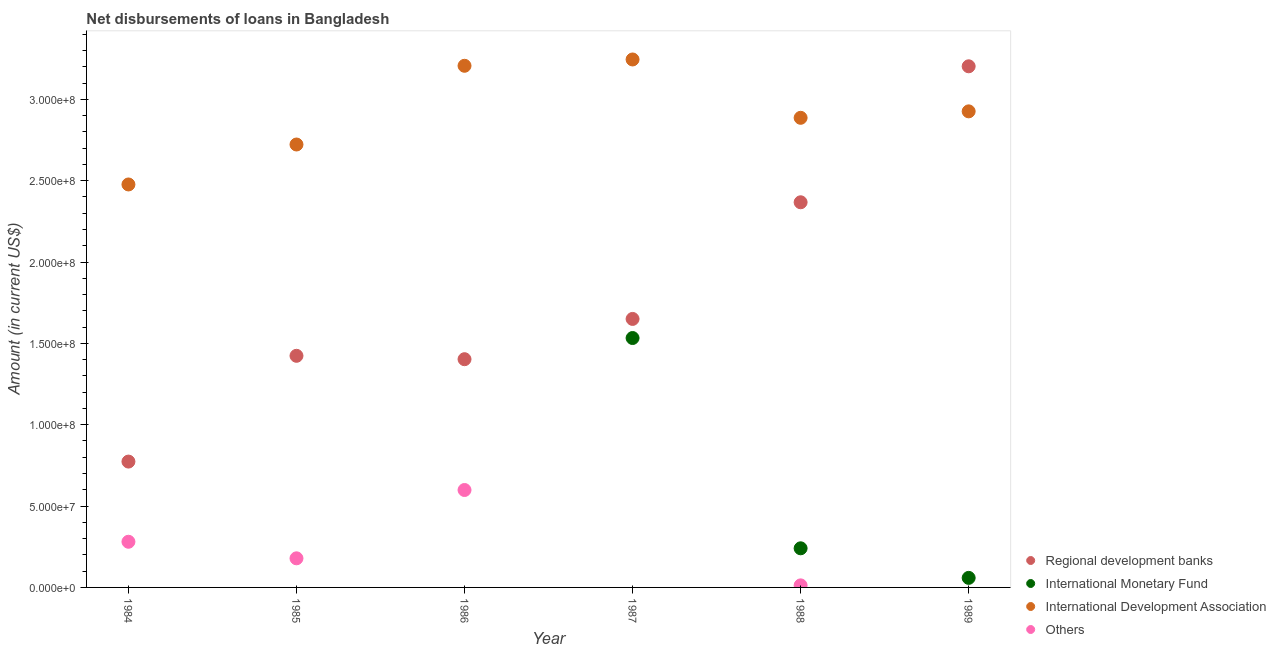How many different coloured dotlines are there?
Your answer should be very brief. 4. What is the amount of loan disimbursed by international monetary fund in 1989?
Make the answer very short. 5.87e+06. Across all years, what is the maximum amount of loan disimbursed by international monetary fund?
Give a very brief answer. 1.53e+08. Across all years, what is the minimum amount of loan disimbursed by international development association?
Keep it short and to the point. 2.48e+08. What is the total amount of loan disimbursed by other organisations in the graph?
Your answer should be compact. 1.07e+08. What is the difference between the amount of loan disimbursed by international development association in 1986 and that in 1989?
Offer a very short reply. 2.80e+07. What is the difference between the amount of loan disimbursed by regional development banks in 1985 and the amount of loan disimbursed by international development association in 1986?
Your answer should be very brief. -1.78e+08. What is the average amount of loan disimbursed by international monetary fund per year?
Offer a terse response. 3.05e+07. In the year 1984, what is the difference between the amount of loan disimbursed by regional development banks and amount of loan disimbursed by international development association?
Your answer should be compact. -1.70e+08. In how many years, is the amount of loan disimbursed by regional development banks greater than 320000000 US$?
Ensure brevity in your answer.  1. What is the ratio of the amount of loan disimbursed by international development association in 1984 to that in 1987?
Your response must be concise. 0.76. Is the amount of loan disimbursed by other organisations in 1985 less than that in 1988?
Offer a very short reply. No. What is the difference between the highest and the second highest amount of loan disimbursed by other organisations?
Ensure brevity in your answer.  3.18e+07. What is the difference between the highest and the lowest amount of loan disimbursed by regional development banks?
Your response must be concise. 2.43e+08. Is the sum of the amount of loan disimbursed by international development association in 1985 and 1986 greater than the maximum amount of loan disimbursed by regional development banks across all years?
Provide a succinct answer. Yes. Is it the case that in every year, the sum of the amount of loan disimbursed by international monetary fund and amount of loan disimbursed by international development association is greater than the sum of amount of loan disimbursed by other organisations and amount of loan disimbursed by regional development banks?
Ensure brevity in your answer.  No. Is the amount of loan disimbursed by other organisations strictly less than the amount of loan disimbursed by international development association over the years?
Make the answer very short. Yes. How many dotlines are there?
Offer a terse response. 4. Are the values on the major ticks of Y-axis written in scientific E-notation?
Give a very brief answer. Yes. Does the graph contain any zero values?
Ensure brevity in your answer.  Yes. Does the graph contain grids?
Your answer should be very brief. No. How are the legend labels stacked?
Your response must be concise. Vertical. What is the title of the graph?
Provide a short and direct response. Net disbursements of loans in Bangladesh. Does "Other expenses" appear as one of the legend labels in the graph?
Your response must be concise. No. What is the Amount (in current US$) of Regional development banks in 1984?
Provide a succinct answer. 7.73e+07. What is the Amount (in current US$) of International Development Association in 1984?
Your response must be concise. 2.48e+08. What is the Amount (in current US$) of Others in 1984?
Make the answer very short. 2.81e+07. What is the Amount (in current US$) in Regional development banks in 1985?
Your response must be concise. 1.42e+08. What is the Amount (in current US$) of International Development Association in 1985?
Provide a short and direct response. 2.72e+08. What is the Amount (in current US$) in Others in 1985?
Your answer should be very brief. 1.79e+07. What is the Amount (in current US$) in Regional development banks in 1986?
Offer a very short reply. 1.40e+08. What is the Amount (in current US$) of International Monetary Fund in 1986?
Provide a succinct answer. 0. What is the Amount (in current US$) in International Development Association in 1986?
Give a very brief answer. 3.21e+08. What is the Amount (in current US$) of Others in 1986?
Make the answer very short. 5.99e+07. What is the Amount (in current US$) in Regional development banks in 1987?
Give a very brief answer. 1.65e+08. What is the Amount (in current US$) of International Monetary Fund in 1987?
Give a very brief answer. 1.53e+08. What is the Amount (in current US$) in International Development Association in 1987?
Offer a very short reply. 3.24e+08. What is the Amount (in current US$) of Regional development banks in 1988?
Ensure brevity in your answer.  2.37e+08. What is the Amount (in current US$) of International Monetary Fund in 1988?
Offer a very short reply. 2.40e+07. What is the Amount (in current US$) in International Development Association in 1988?
Keep it short and to the point. 2.89e+08. What is the Amount (in current US$) of Others in 1988?
Provide a succinct answer. 1.26e+06. What is the Amount (in current US$) of Regional development banks in 1989?
Make the answer very short. 3.20e+08. What is the Amount (in current US$) in International Monetary Fund in 1989?
Your answer should be very brief. 5.87e+06. What is the Amount (in current US$) of International Development Association in 1989?
Make the answer very short. 2.93e+08. Across all years, what is the maximum Amount (in current US$) in Regional development banks?
Keep it short and to the point. 3.20e+08. Across all years, what is the maximum Amount (in current US$) in International Monetary Fund?
Your answer should be very brief. 1.53e+08. Across all years, what is the maximum Amount (in current US$) in International Development Association?
Provide a short and direct response. 3.24e+08. Across all years, what is the maximum Amount (in current US$) in Others?
Ensure brevity in your answer.  5.99e+07. Across all years, what is the minimum Amount (in current US$) in Regional development banks?
Give a very brief answer. 7.73e+07. Across all years, what is the minimum Amount (in current US$) of International Monetary Fund?
Provide a short and direct response. 0. Across all years, what is the minimum Amount (in current US$) of International Development Association?
Give a very brief answer. 2.48e+08. Across all years, what is the minimum Amount (in current US$) in Others?
Provide a short and direct response. 0. What is the total Amount (in current US$) in Regional development banks in the graph?
Your answer should be very brief. 1.08e+09. What is the total Amount (in current US$) in International Monetary Fund in the graph?
Provide a short and direct response. 1.83e+08. What is the total Amount (in current US$) of International Development Association in the graph?
Ensure brevity in your answer.  1.75e+09. What is the total Amount (in current US$) in Others in the graph?
Your answer should be compact. 1.07e+08. What is the difference between the Amount (in current US$) in Regional development banks in 1984 and that in 1985?
Ensure brevity in your answer.  -6.50e+07. What is the difference between the Amount (in current US$) in International Development Association in 1984 and that in 1985?
Provide a succinct answer. -2.46e+07. What is the difference between the Amount (in current US$) of Others in 1984 and that in 1985?
Offer a very short reply. 1.02e+07. What is the difference between the Amount (in current US$) in Regional development banks in 1984 and that in 1986?
Offer a terse response. -6.29e+07. What is the difference between the Amount (in current US$) of International Development Association in 1984 and that in 1986?
Provide a short and direct response. -7.29e+07. What is the difference between the Amount (in current US$) of Others in 1984 and that in 1986?
Give a very brief answer. -3.18e+07. What is the difference between the Amount (in current US$) of Regional development banks in 1984 and that in 1987?
Your answer should be compact. -8.77e+07. What is the difference between the Amount (in current US$) in International Development Association in 1984 and that in 1987?
Ensure brevity in your answer.  -7.68e+07. What is the difference between the Amount (in current US$) of Regional development banks in 1984 and that in 1988?
Provide a succinct answer. -1.59e+08. What is the difference between the Amount (in current US$) of International Development Association in 1984 and that in 1988?
Ensure brevity in your answer.  -4.10e+07. What is the difference between the Amount (in current US$) of Others in 1984 and that in 1988?
Make the answer very short. 2.68e+07. What is the difference between the Amount (in current US$) of Regional development banks in 1984 and that in 1989?
Your answer should be compact. -2.43e+08. What is the difference between the Amount (in current US$) in International Development Association in 1984 and that in 1989?
Your response must be concise. -4.49e+07. What is the difference between the Amount (in current US$) of Regional development banks in 1985 and that in 1986?
Offer a terse response. 2.08e+06. What is the difference between the Amount (in current US$) of International Development Association in 1985 and that in 1986?
Give a very brief answer. -4.84e+07. What is the difference between the Amount (in current US$) in Others in 1985 and that in 1986?
Offer a terse response. -4.20e+07. What is the difference between the Amount (in current US$) in Regional development banks in 1985 and that in 1987?
Offer a very short reply. -2.27e+07. What is the difference between the Amount (in current US$) in International Development Association in 1985 and that in 1987?
Make the answer very short. -5.23e+07. What is the difference between the Amount (in current US$) in Regional development banks in 1985 and that in 1988?
Your answer should be compact. -9.44e+07. What is the difference between the Amount (in current US$) in International Development Association in 1985 and that in 1988?
Your answer should be compact. -1.64e+07. What is the difference between the Amount (in current US$) of Others in 1985 and that in 1988?
Offer a very short reply. 1.66e+07. What is the difference between the Amount (in current US$) of Regional development banks in 1985 and that in 1989?
Keep it short and to the point. -1.78e+08. What is the difference between the Amount (in current US$) of International Development Association in 1985 and that in 1989?
Keep it short and to the point. -2.04e+07. What is the difference between the Amount (in current US$) in Regional development banks in 1986 and that in 1987?
Ensure brevity in your answer.  -2.48e+07. What is the difference between the Amount (in current US$) in International Development Association in 1986 and that in 1987?
Provide a short and direct response. -3.88e+06. What is the difference between the Amount (in current US$) of Regional development banks in 1986 and that in 1988?
Your answer should be compact. -9.64e+07. What is the difference between the Amount (in current US$) in International Development Association in 1986 and that in 1988?
Your answer should be compact. 3.20e+07. What is the difference between the Amount (in current US$) of Others in 1986 and that in 1988?
Offer a very short reply. 5.86e+07. What is the difference between the Amount (in current US$) of Regional development banks in 1986 and that in 1989?
Provide a short and direct response. -1.80e+08. What is the difference between the Amount (in current US$) in International Development Association in 1986 and that in 1989?
Give a very brief answer. 2.80e+07. What is the difference between the Amount (in current US$) of Regional development banks in 1987 and that in 1988?
Make the answer very short. -7.17e+07. What is the difference between the Amount (in current US$) of International Monetary Fund in 1987 and that in 1988?
Provide a short and direct response. 1.29e+08. What is the difference between the Amount (in current US$) of International Development Association in 1987 and that in 1988?
Offer a terse response. 3.59e+07. What is the difference between the Amount (in current US$) in Regional development banks in 1987 and that in 1989?
Your answer should be very brief. -1.55e+08. What is the difference between the Amount (in current US$) in International Monetary Fund in 1987 and that in 1989?
Offer a very short reply. 1.47e+08. What is the difference between the Amount (in current US$) in International Development Association in 1987 and that in 1989?
Make the answer very short. 3.19e+07. What is the difference between the Amount (in current US$) of Regional development banks in 1988 and that in 1989?
Give a very brief answer. -8.36e+07. What is the difference between the Amount (in current US$) in International Monetary Fund in 1988 and that in 1989?
Provide a short and direct response. 1.82e+07. What is the difference between the Amount (in current US$) of International Development Association in 1988 and that in 1989?
Provide a succinct answer. -3.96e+06. What is the difference between the Amount (in current US$) of Regional development banks in 1984 and the Amount (in current US$) of International Development Association in 1985?
Provide a succinct answer. -1.95e+08. What is the difference between the Amount (in current US$) of Regional development banks in 1984 and the Amount (in current US$) of Others in 1985?
Your response must be concise. 5.95e+07. What is the difference between the Amount (in current US$) in International Development Association in 1984 and the Amount (in current US$) in Others in 1985?
Your answer should be compact. 2.30e+08. What is the difference between the Amount (in current US$) of Regional development banks in 1984 and the Amount (in current US$) of International Development Association in 1986?
Provide a short and direct response. -2.43e+08. What is the difference between the Amount (in current US$) of Regional development banks in 1984 and the Amount (in current US$) of Others in 1986?
Your answer should be very brief. 1.75e+07. What is the difference between the Amount (in current US$) in International Development Association in 1984 and the Amount (in current US$) in Others in 1986?
Make the answer very short. 1.88e+08. What is the difference between the Amount (in current US$) of Regional development banks in 1984 and the Amount (in current US$) of International Monetary Fund in 1987?
Give a very brief answer. -7.59e+07. What is the difference between the Amount (in current US$) in Regional development banks in 1984 and the Amount (in current US$) in International Development Association in 1987?
Your answer should be very brief. -2.47e+08. What is the difference between the Amount (in current US$) in Regional development banks in 1984 and the Amount (in current US$) in International Monetary Fund in 1988?
Keep it short and to the point. 5.33e+07. What is the difference between the Amount (in current US$) in Regional development banks in 1984 and the Amount (in current US$) in International Development Association in 1988?
Ensure brevity in your answer.  -2.11e+08. What is the difference between the Amount (in current US$) in Regional development banks in 1984 and the Amount (in current US$) in Others in 1988?
Provide a succinct answer. 7.61e+07. What is the difference between the Amount (in current US$) of International Development Association in 1984 and the Amount (in current US$) of Others in 1988?
Provide a short and direct response. 2.46e+08. What is the difference between the Amount (in current US$) in Regional development banks in 1984 and the Amount (in current US$) in International Monetary Fund in 1989?
Your response must be concise. 7.15e+07. What is the difference between the Amount (in current US$) of Regional development banks in 1984 and the Amount (in current US$) of International Development Association in 1989?
Your response must be concise. -2.15e+08. What is the difference between the Amount (in current US$) in Regional development banks in 1985 and the Amount (in current US$) in International Development Association in 1986?
Your answer should be compact. -1.78e+08. What is the difference between the Amount (in current US$) in Regional development banks in 1985 and the Amount (in current US$) in Others in 1986?
Your response must be concise. 8.25e+07. What is the difference between the Amount (in current US$) in International Development Association in 1985 and the Amount (in current US$) in Others in 1986?
Offer a terse response. 2.12e+08. What is the difference between the Amount (in current US$) in Regional development banks in 1985 and the Amount (in current US$) in International Monetary Fund in 1987?
Keep it short and to the point. -1.09e+07. What is the difference between the Amount (in current US$) in Regional development banks in 1985 and the Amount (in current US$) in International Development Association in 1987?
Make the answer very short. -1.82e+08. What is the difference between the Amount (in current US$) in Regional development banks in 1985 and the Amount (in current US$) in International Monetary Fund in 1988?
Make the answer very short. 1.18e+08. What is the difference between the Amount (in current US$) of Regional development banks in 1985 and the Amount (in current US$) of International Development Association in 1988?
Your response must be concise. -1.46e+08. What is the difference between the Amount (in current US$) in Regional development banks in 1985 and the Amount (in current US$) in Others in 1988?
Your response must be concise. 1.41e+08. What is the difference between the Amount (in current US$) of International Development Association in 1985 and the Amount (in current US$) of Others in 1988?
Offer a very short reply. 2.71e+08. What is the difference between the Amount (in current US$) in Regional development banks in 1985 and the Amount (in current US$) in International Monetary Fund in 1989?
Offer a terse response. 1.36e+08. What is the difference between the Amount (in current US$) of Regional development banks in 1985 and the Amount (in current US$) of International Development Association in 1989?
Provide a succinct answer. -1.50e+08. What is the difference between the Amount (in current US$) of Regional development banks in 1986 and the Amount (in current US$) of International Monetary Fund in 1987?
Your response must be concise. -1.30e+07. What is the difference between the Amount (in current US$) of Regional development banks in 1986 and the Amount (in current US$) of International Development Association in 1987?
Offer a terse response. -1.84e+08. What is the difference between the Amount (in current US$) of Regional development banks in 1986 and the Amount (in current US$) of International Monetary Fund in 1988?
Ensure brevity in your answer.  1.16e+08. What is the difference between the Amount (in current US$) of Regional development banks in 1986 and the Amount (in current US$) of International Development Association in 1988?
Ensure brevity in your answer.  -1.48e+08. What is the difference between the Amount (in current US$) of Regional development banks in 1986 and the Amount (in current US$) of Others in 1988?
Offer a very short reply. 1.39e+08. What is the difference between the Amount (in current US$) in International Development Association in 1986 and the Amount (in current US$) in Others in 1988?
Offer a terse response. 3.19e+08. What is the difference between the Amount (in current US$) of Regional development banks in 1986 and the Amount (in current US$) of International Monetary Fund in 1989?
Make the answer very short. 1.34e+08. What is the difference between the Amount (in current US$) of Regional development banks in 1986 and the Amount (in current US$) of International Development Association in 1989?
Offer a terse response. -1.52e+08. What is the difference between the Amount (in current US$) in Regional development banks in 1987 and the Amount (in current US$) in International Monetary Fund in 1988?
Make the answer very short. 1.41e+08. What is the difference between the Amount (in current US$) of Regional development banks in 1987 and the Amount (in current US$) of International Development Association in 1988?
Your answer should be compact. -1.24e+08. What is the difference between the Amount (in current US$) of Regional development banks in 1987 and the Amount (in current US$) of Others in 1988?
Your response must be concise. 1.64e+08. What is the difference between the Amount (in current US$) in International Monetary Fund in 1987 and the Amount (in current US$) in International Development Association in 1988?
Provide a succinct answer. -1.35e+08. What is the difference between the Amount (in current US$) in International Monetary Fund in 1987 and the Amount (in current US$) in Others in 1988?
Ensure brevity in your answer.  1.52e+08. What is the difference between the Amount (in current US$) in International Development Association in 1987 and the Amount (in current US$) in Others in 1988?
Your answer should be compact. 3.23e+08. What is the difference between the Amount (in current US$) of Regional development banks in 1987 and the Amount (in current US$) of International Monetary Fund in 1989?
Provide a succinct answer. 1.59e+08. What is the difference between the Amount (in current US$) in Regional development banks in 1987 and the Amount (in current US$) in International Development Association in 1989?
Provide a succinct answer. -1.28e+08. What is the difference between the Amount (in current US$) of International Monetary Fund in 1987 and the Amount (in current US$) of International Development Association in 1989?
Your response must be concise. -1.39e+08. What is the difference between the Amount (in current US$) in Regional development banks in 1988 and the Amount (in current US$) in International Monetary Fund in 1989?
Make the answer very short. 2.31e+08. What is the difference between the Amount (in current US$) in Regional development banks in 1988 and the Amount (in current US$) in International Development Association in 1989?
Give a very brief answer. -5.59e+07. What is the difference between the Amount (in current US$) in International Monetary Fund in 1988 and the Amount (in current US$) in International Development Association in 1989?
Offer a terse response. -2.69e+08. What is the average Amount (in current US$) in Regional development banks per year?
Your response must be concise. 1.80e+08. What is the average Amount (in current US$) in International Monetary Fund per year?
Make the answer very short. 3.05e+07. What is the average Amount (in current US$) of International Development Association per year?
Offer a terse response. 2.91e+08. What is the average Amount (in current US$) in Others per year?
Make the answer very short. 1.78e+07. In the year 1984, what is the difference between the Amount (in current US$) of Regional development banks and Amount (in current US$) of International Development Association?
Offer a terse response. -1.70e+08. In the year 1984, what is the difference between the Amount (in current US$) in Regional development banks and Amount (in current US$) in Others?
Offer a very short reply. 4.93e+07. In the year 1984, what is the difference between the Amount (in current US$) in International Development Association and Amount (in current US$) in Others?
Your answer should be very brief. 2.20e+08. In the year 1985, what is the difference between the Amount (in current US$) of Regional development banks and Amount (in current US$) of International Development Association?
Provide a succinct answer. -1.30e+08. In the year 1985, what is the difference between the Amount (in current US$) of Regional development banks and Amount (in current US$) of Others?
Offer a very short reply. 1.24e+08. In the year 1985, what is the difference between the Amount (in current US$) in International Development Association and Amount (in current US$) in Others?
Keep it short and to the point. 2.54e+08. In the year 1986, what is the difference between the Amount (in current US$) in Regional development banks and Amount (in current US$) in International Development Association?
Provide a succinct answer. -1.80e+08. In the year 1986, what is the difference between the Amount (in current US$) in Regional development banks and Amount (in current US$) in Others?
Your answer should be very brief. 8.04e+07. In the year 1986, what is the difference between the Amount (in current US$) in International Development Association and Amount (in current US$) in Others?
Offer a terse response. 2.61e+08. In the year 1987, what is the difference between the Amount (in current US$) of Regional development banks and Amount (in current US$) of International Monetary Fund?
Ensure brevity in your answer.  1.17e+07. In the year 1987, what is the difference between the Amount (in current US$) of Regional development banks and Amount (in current US$) of International Development Association?
Your answer should be compact. -1.59e+08. In the year 1987, what is the difference between the Amount (in current US$) in International Monetary Fund and Amount (in current US$) in International Development Association?
Your answer should be very brief. -1.71e+08. In the year 1988, what is the difference between the Amount (in current US$) in Regional development banks and Amount (in current US$) in International Monetary Fund?
Ensure brevity in your answer.  2.13e+08. In the year 1988, what is the difference between the Amount (in current US$) of Regional development banks and Amount (in current US$) of International Development Association?
Your answer should be compact. -5.19e+07. In the year 1988, what is the difference between the Amount (in current US$) in Regional development banks and Amount (in current US$) in Others?
Offer a terse response. 2.35e+08. In the year 1988, what is the difference between the Amount (in current US$) in International Monetary Fund and Amount (in current US$) in International Development Association?
Provide a succinct answer. -2.65e+08. In the year 1988, what is the difference between the Amount (in current US$) of International Monetary Fund and Amount (in current US$) of Others?
Give a very brief answer. 2.28e+07. In the year 1988, what is the difference between the Amount (in current US$) of International Development Association and Amount (in current US$) of Others?
Keep it short and to the point. 2.87e+08. In the year 1989, what is the difference between the Amount (in current US$) of Regional development banks and Amount (in current US$) of International Monetary Fund?
Offer a terse response. 3.14e+08. In the year 1989, what is the difference between the Amount (in current US$) of Regional development banks and Amount (in current US$) of International Development Association?
Provide a succinct answer. 2.77e+07. In the year 1989, what is the difference between the Amount (in current US$) of International Monetary Fund and Amount (in current US$) of International Development Association?
Keep it short and to the point. -2.87e+08. What is the ratio of the Amount (in current US$) of Regional development banks in 1984 to that in 1985?
Provide a short and direct response. 0.54. What is the ratio of the Amount (in current US$) in International Development Association in 1984 to that in 1985?
Offer a very short reply. 0.91. What is the ratio of the Amount (in current US$) in Others in 1984 to that in 1985?
Offer a very short reply. 1.57. What is the ratio of the Amount (in current US$) in Regional development banks in 1984 to that in 1986?
Your answer should be very brief. 0.55. What is the ratio of the Amount (in current US$) in International Development Association in 1984 to that in 1986?
Ensure brevity in your answer.  0.77. What is the ratio of the Amount (in current US$) of Others in 1984 to that in 1986?
Provide a short and direct response. 0.47. What is the ratio of the Amount (in current US$) in Regional development banks in 1984 to that in 1987?
Offer a very short reply. 0.47. What is the ratio of the Amount (in current US$) of International Development Association in 1984 to that in 1987?
Your response must be concise. 0.76. What is the ratio of the Amount (in current US$) of Regional development banks in 1984 to that in 1988?
Your answer should be very brief. 0.33. What is the ratio of the Amount (in current US$) in International Development Association in 1984 to that in 1988?
Provide a short and direct response. 0.86. What is the ratio of the Amount (in current US$) in Others in 1984 to that in 1988?
Your answer should be very brief. 22.19. What is the ratio of the Amount (in current US$) of Regional development banks in 1984 to that in 1989?
Your answer should be compact. 0.24. What is the ratio of the Amount (in current US$) of International Development Association in 1984 to that in 1989?
Provide a succinct answer. 0.85. What is the ratio of the Amount (in current US$) of Regional development banks in 1985 to that in 1986?
Your answer should be compact. 1.01. What is the ratio of the Amount (in current US$) of International Development Association in 1985 to that in 1986?
Your answer should be compact. 0.85. What is the ratio of the Amount (in current US$) in Others in 1985 to that in 1986?
Give a very brief answer. 0.3. What is the ratio of the Amount (in current US$) of Regional development banks in 1985 to that in 1987?
Ensure brevity in your answer.  0.86. What is the ratio of the Amount (in current US$) in International Development Association in 1985 to that in 1987?
Give a very brief answer. 0.84. What is the ratio of the Amount (in current US$) in Regional development banks in 1985 to that in 1988?
Offer a very short reply. 0.6. What is the ratio of the Amount (in current US$) in International Development Association in 1985 to that in 1988?
Provide a succinct answer. 0.94. What is the ratio of the Amount (in current US$) in Others in 1985 to that in 1988?
Provide a succinct answer. 14.14. What is the ratio of the Amount (in current US$) in Regional development banks in 1985 to that in 1989?
Your answer should be compact. 0.44. What is the ratio of the Amount (in current US$) of International Development Association in 1985 to that in 1989?
Offer a terse response. 0.93. What is the ratio of the Amount (in current US$) in Regional development banks in 1986 to that in 1987?
Ensure brevity in your answer.  0.85. What is the ratio of the Amount (in current US$) of Regional development banks in 1986 to that in 1988?
Give a very brief answer. 0.59. What is the ratio of the Amount (in current US$) of International Development Association in 1986 to that in 1988?
Your answer should be very brief. 1.11. What is the ratio of the Amount (in current US$) in Others in 1986 to that in 1988?
Your answer should be very brief. 47.33. What is the ratio of the Amount (in current US$) in Regional development banks in 1986 to that in 1989?
Your response must be concise. 0.44. What is the ratio of the Amount (in current US$) in International Development Association in 1986 to that in 1989?
Keep it short and to the point. 1.1. What is the ratio of the Amount (in current US$) of Regional development banks in 1987 to that in 1988?
Make the answer very short. 0.7. What is the ratio of the Amount (in current US$) of International Monetary Fund in 1987 to that in 1988?
Your response must be concise. 6.38. What is the ratio of the Amount (in current US$) of International Development Association in 1987 to that in 1988?
Make the answer very short. 1.12. What is the ratio of the Amount (in current US$) in Regional development banks in 1987 to that in 1989?
Provide a short and direct response. 0.52. What is the ratio of the Amount (in current US$) in International Monetary Fund in 1987 to that in 1989?
Offer a terse response. 26.12. What is the ratio of the Amount (in current US$) in International Development Association in 1987 to that in 1989?
Make the answer very short. 1.11. What is the ratio of the Amount (in current US$) of Regional development banks in 1988 to that in 1989?
Offer a very short reply. 0.74. What is the ratio of the Amount (in current US$) of International Monetary Fund in 1988 to that in 1989?
Your answer should be compact. 4.1. What is the ratio of the Amount (in current US$) of International Development Association in 1988 to that in 1989?
Make the answer very short. 0.99. What is the difference between the highest and the second highest Amount (in current US$) of Regional development banks?
Provide a short and direct response. 8.36e+07. What is the difference between the highest and the second highest Amount (in current US$) of International Monetary Fund?
Give a very brief answer. 1.29e+08. What is the difference between the highest and the second highest Amount (in current US$) of International Development Association?
Keep it short and to the point. 3.88e+06. What is the difference between the highest and the second highest Amount (in current US$) of Others?
Offer a very short reply. 3.18e+07. What is the difference between the highest and the lowest Amount (in current US$) in Regional development banks?
Give a very brief answer. 2.43e+08. What is the difference between the highest and the lowest Amount (in current US$) in International Monetary Fund?
Offer a terse response. 1.53e+08. What is the difference between the highest and the lowest Amount (in current US$) of International Development Association?
Offer a very short reply. 7.68e+07. What is the difference between the highest and the lowest Amount (in current US$) in Others?
Keep it short and to the point. 5.99e+07. 